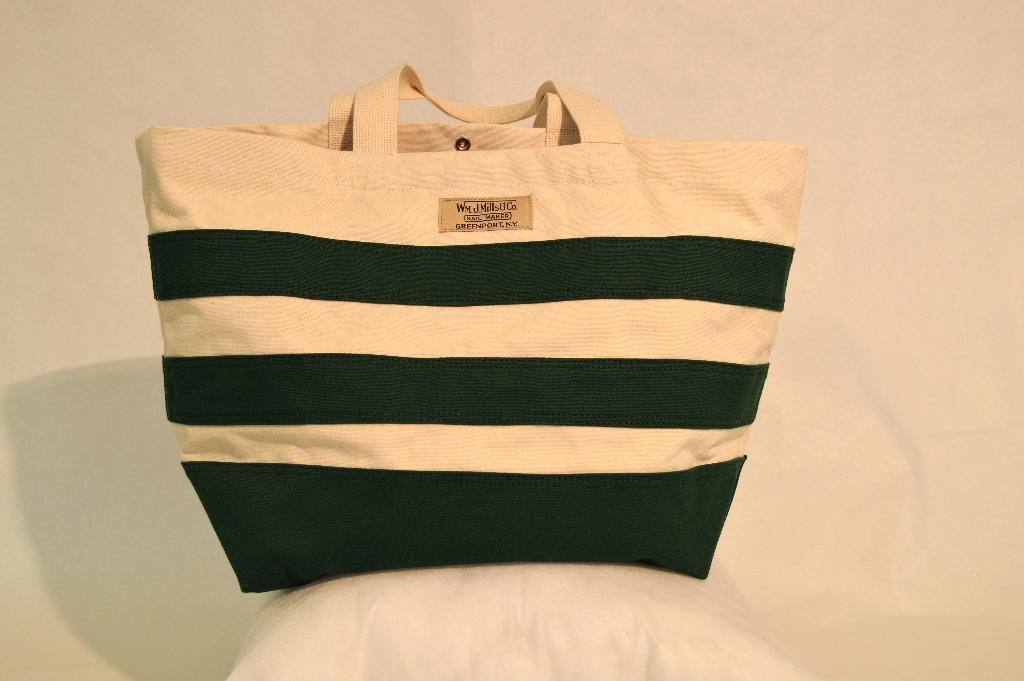What object is the main focus of the image? There is a handbag in the image. What color is the background of the image? The background of the image is in cream color. How many sons does the creator of the handbag have? There is no information about the creator of the handbag or their sons in the image. 